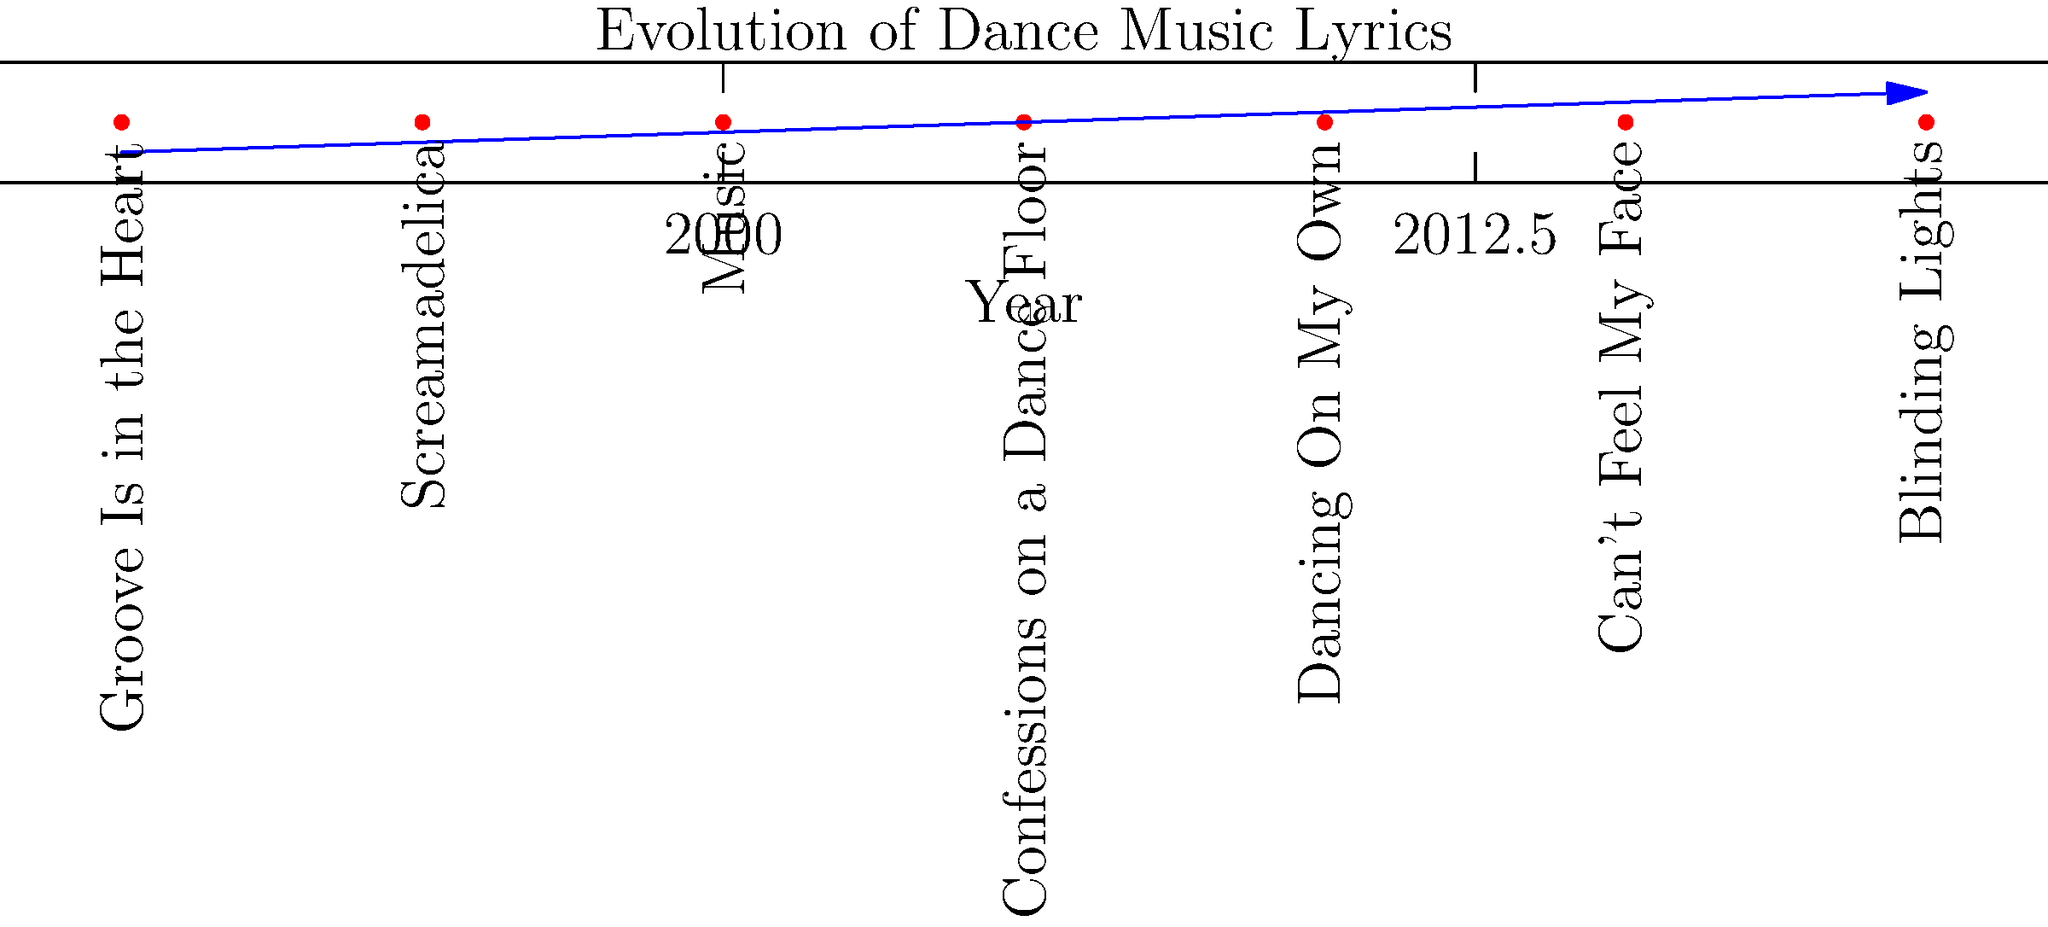Based on the timeline of iconic dance songs, which artist's work in 2005 marked a significant shift towards more introspective and personal lyrics in mainstream dance music? To answer this question, we need to analyze the evolution of dance music lyrics represented in the timeline:

1. 1990: "Groove Is in the Heart" by Deee-Lite - Known for its fun, lighthearted lyrics.
2. 1995: "Screamadelica" by Primal Scream - Psychedelic-influenced dance rock with abstract lyrics.
3. 2000: "Music" by Madonna - Upbeat party anthem with straightforward lyrics.
4. 2005: "Confessions on a Dance Floor" by Madonna - This album marked a shift towards more personal and introspective lyrics while maintaining a dance-oriented sound.
5. 2010: "Dancing On My Own" by Robyn - Emotional lyrics combined with dance beats.
6. 2015: "Can't Feel My Face" by The Weeknd - Metaphorical lyrics with a dance pop sound.
7. 2020: "Blinding Lights" by The Weeknd - Nostalgic sound with personal lyrics.

The significant shift towards more introspective and personal lyrics in mainstream dance music can be traced to Madonna's 2005 album "Confessions on a Dance Floor." This album combined deeply personal themes with dance-oriented production, influencing subsequent artists to explore more meaningful lyrical content in dance music.
Answer: Madonna 